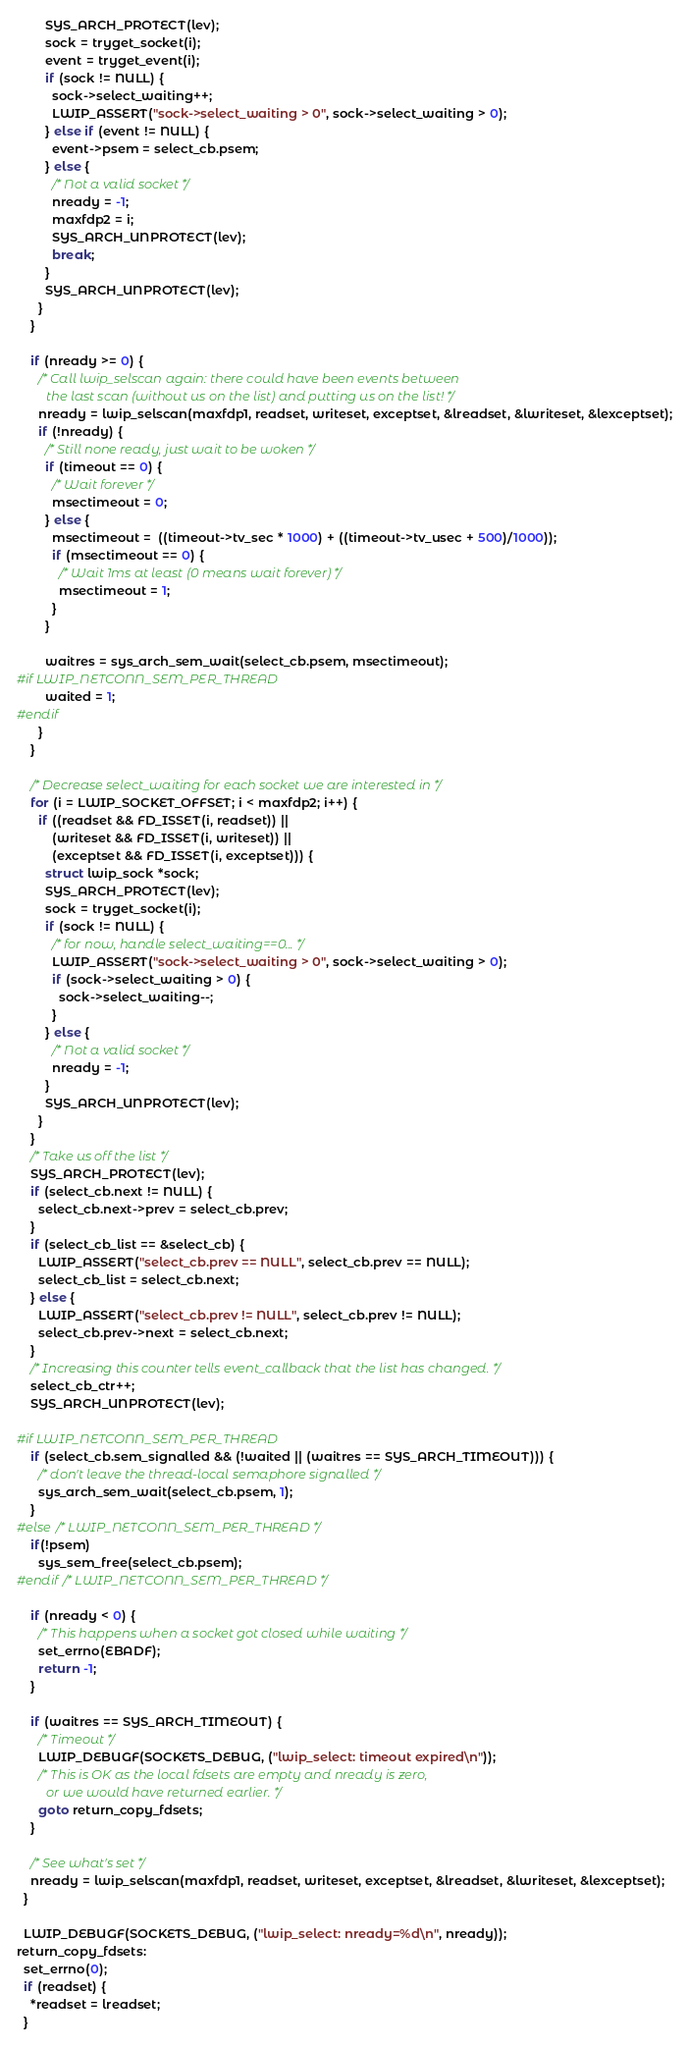<code> <loc_0><loc_0><loc_500><loc_500><_C_>        SYS_ARCH_PROTECT(lev);
        sock = tryget_socket(i);
        event = tryget_event(i);
        if (sock != NULL) {
          sock->select_waiting++;
          LWIP_ASSERT("sock->select_waiting > 0", sock->select_waiting > 0);
        } else if (event != NULL) {
          event->psem = select_cb.psem;
        } else {
          /* Not a valid socket */
          nready = -1;
          maxfdp2 = i;
          SYS_ARCH_UNPROTECT(lev);
          break;
        }
        SYS_ARCH_UNPROTECT(lev);
      }
    }

    if (nready >= 0) {
      /* Call lwip_selscan again: there could have been events between
         the last scan (without us on the list) and putting us on the list! */
      nready = lwip_selscan(maxfdp1, readset, writeset, exceptset, &lreadset, &lwriteset, &lexceptset);
      if (!nready) {
        /* Still none ready, just wait to be woken */
        if (timeout == 0) {
          /* Wait forever */
          msectimeout = 0;
        } else {
          msectimeout =  ((timeout->tv_sec * 1000) + ((timeout->tv_usec + 500)/1000));
          if (msectimeout == 0) {
            /* Wait 1ms at least (0 means wait forever) */
            msectimeout = 1;
          }
        }

        waitres = sys_arch_sem_wait(select_cb.psem, msectimeout);
#if LWIP_NETCONN_SEM_PER_THREAD
        waited = 1;
#endif
      }
    }

    /* Decrease select_waiting for each socket we are interested in */
    for (i = LWIP_SOCKET_OFFSET; i < maxfdp2; i++) {
      if ((readset && FD_ISSET(i, readset)) ||
          (writeset && FD_ISSET(i, writeset)) ||
          (exceptset && FD_ISSET(i, exceptset))) {
        struct lwip_sock *sock;
        SYS_ARCH_PROTECT(lev);
        sock = tryget_socket(i);
        if (sock != NULL) {
          /* for now, handle select_waiting==0... */
          LWIP_ASSERT("sock->select_waiting > 0", sock->select_waiting > 0);
          if (sock->select_waiting > 0) {
            sock->select_waiting--;
          }
        } else {
          /* Not a valid socket */
          nready = -1;
        }
        SYS_ARCH_UNPROTECT(lev);
      }
    }
    /* Take us off the list */
    SYS_ARCH_PROTECT(lev);
    if (select_cb.next != NULL) {
      select_cb.next->prev = select_cb.prev;
    }
    if (select_cb_list == &select_cb) {
      LWIP_ASSERT("select_cb.prev == NULL", select_cb.prev == NULL);
      select_cb_list = select_cb.next;
    } else {
      LWIP_ASSERT("select_cb.prev != NULL", select_cb.prev != NULL);
      select_cb.prev->next = select_cb.next;
    }
    /* Increasing this counter tells event_callback that the list has changed. */
    select_cb_ctr++;
    SYS_ARCH_UNPROTECT(lev);

#if LWIP_NETCONN_SEM_PER_THREAD
    if (select_cb.sem_signalled && (!waited || (waitres == SYS_ARCH_TIMEOUT))) {
      /* don't leave the thread-local semaphore signalled */
      sys_arch_sem_wait(select_cb.psem, 1);
    }
#else /* LWIP_NETCONN_SEM_PER_THREAD */
    if(!psem)
      sys_sem_free(select_cb.psem);
#endif /* LWIP_NETCONN_SEM_PER_THREAD */

    if (nready < 0) {
      /* This happens when a socket got closed while waiting */
      set_errno(EBADF);
      return -1;
    }

    if (waitres == SYS_ARCH_TIMEOUT) {
      /* Timeout */
      LWIP_DEBUGF(SOCKETS_DEBUG, ("lwip_select: timeout expired\n"));
      /* This is OK as the local fdsets are empty and nready is zero,
         or we would have returned earlier. */
      goto return_copy_fdsets;
    }

    /* See what's set */
    nready = lwip_selscan(maxfdp1, readset, writeset, exceptset, &lreadset, &lwriteset, &lexceptset);
  }

  LWIP_DEBUGF(SOCKETS_DEBUG, ("lwip_select: nready=%d\n", nready));
return_copy_fdsets:
  set_errno(0);
  if (readset) {
    *readset = lreadset;
  }</code> 